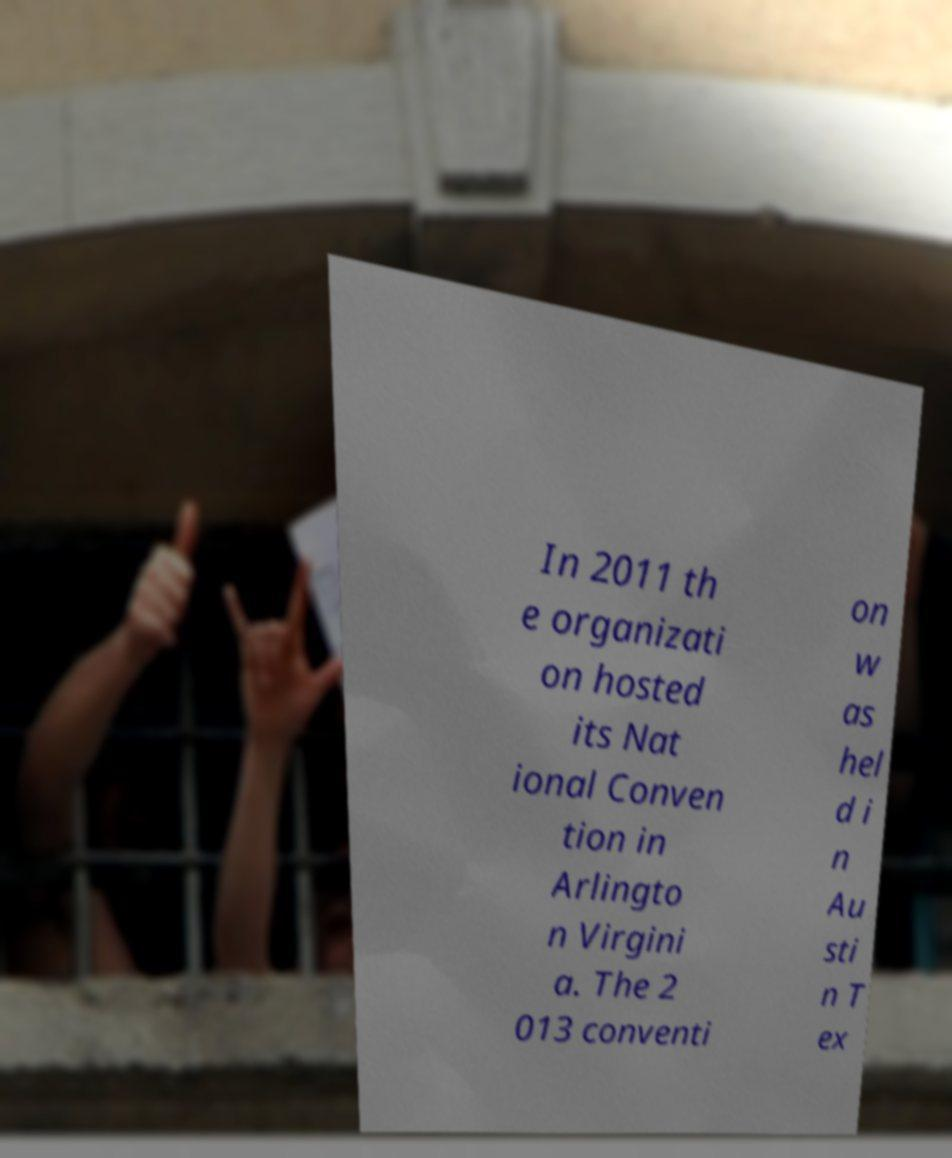Could you assist in decoding the text presented in this image and type it out clearly? In 2011 th e organizati on hosted its Nat ional Conven tion in Arlingto n Virgini a. The 2 013 conventi on w as hel d i n Au sti n T ex 